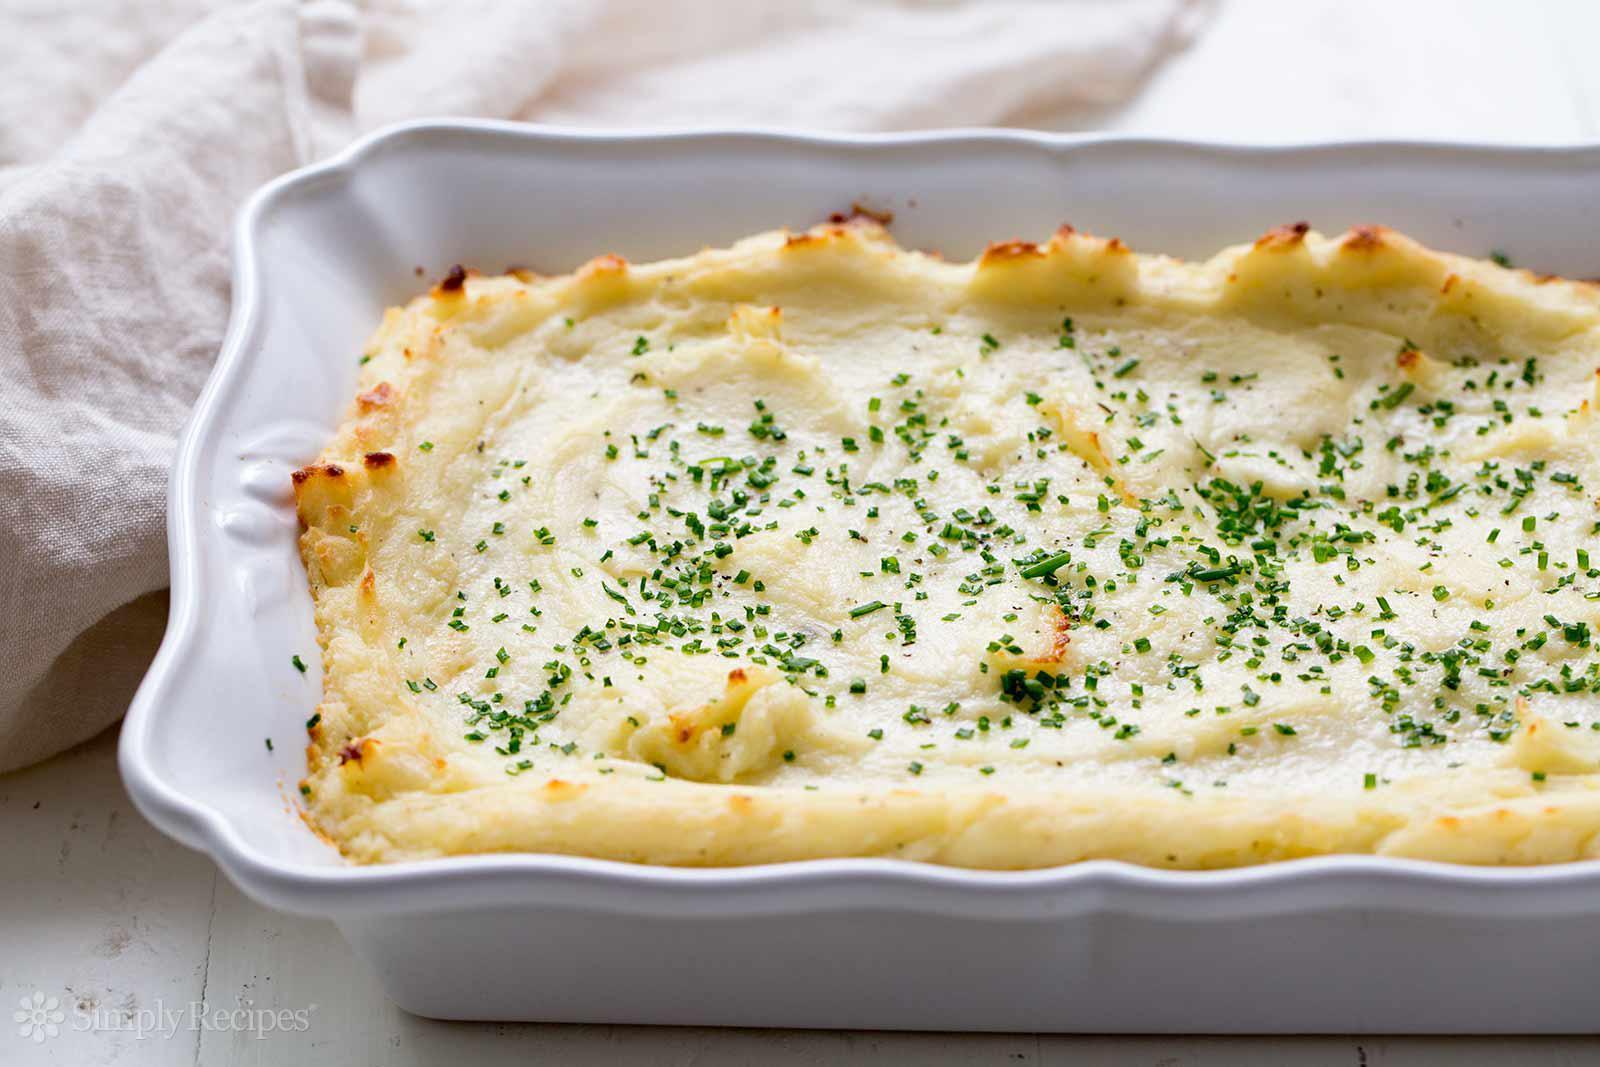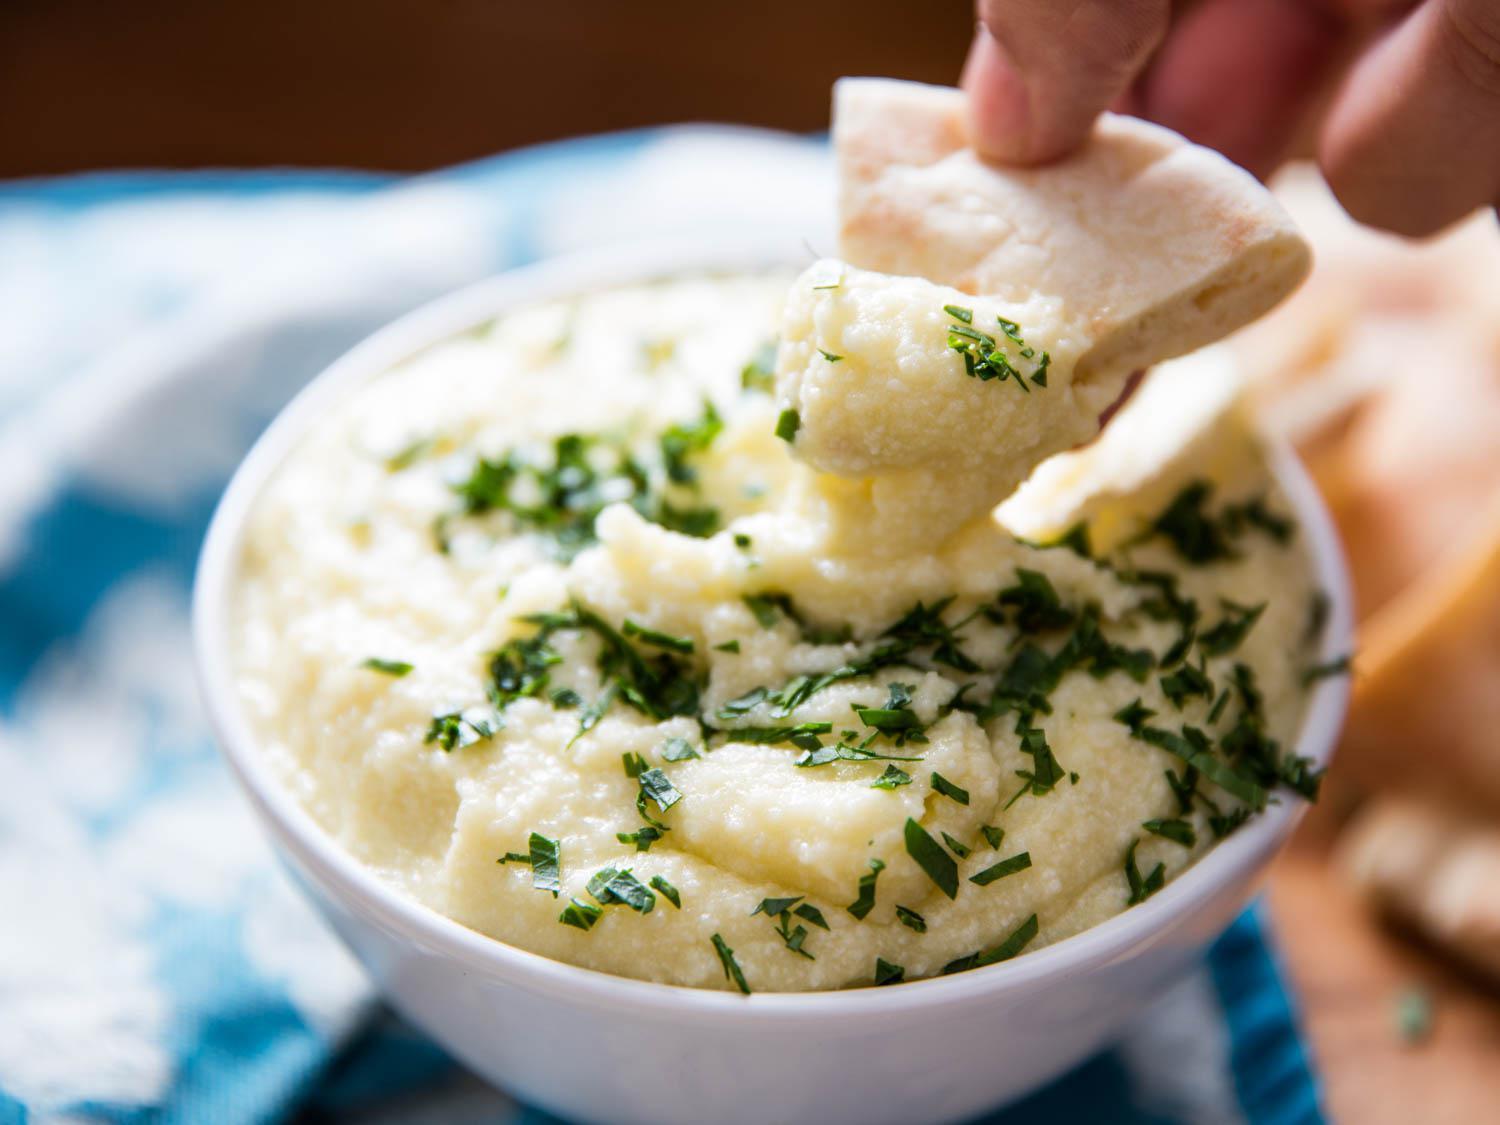The first image is the image on the left, the second image is the image on the right. Evaluate the accuracy of this statement regarding the images: "Left image shows mashed potatoes in a round bowl with fluted edges.". Is it true? Answer yes or no. No. The first image is the image on the left, the second image is the image on the right. Examine the images to the left and right. Is the description "The right image contains a spoon, the left image does not, and there is no food outside of the bowl." accurate? Answer yes or no. No. 